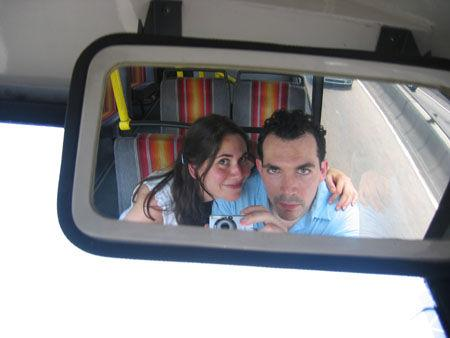They are taking this photo in what? Please explain your reasoning. bus. The people are taking a photo while sitting in bus seats. 